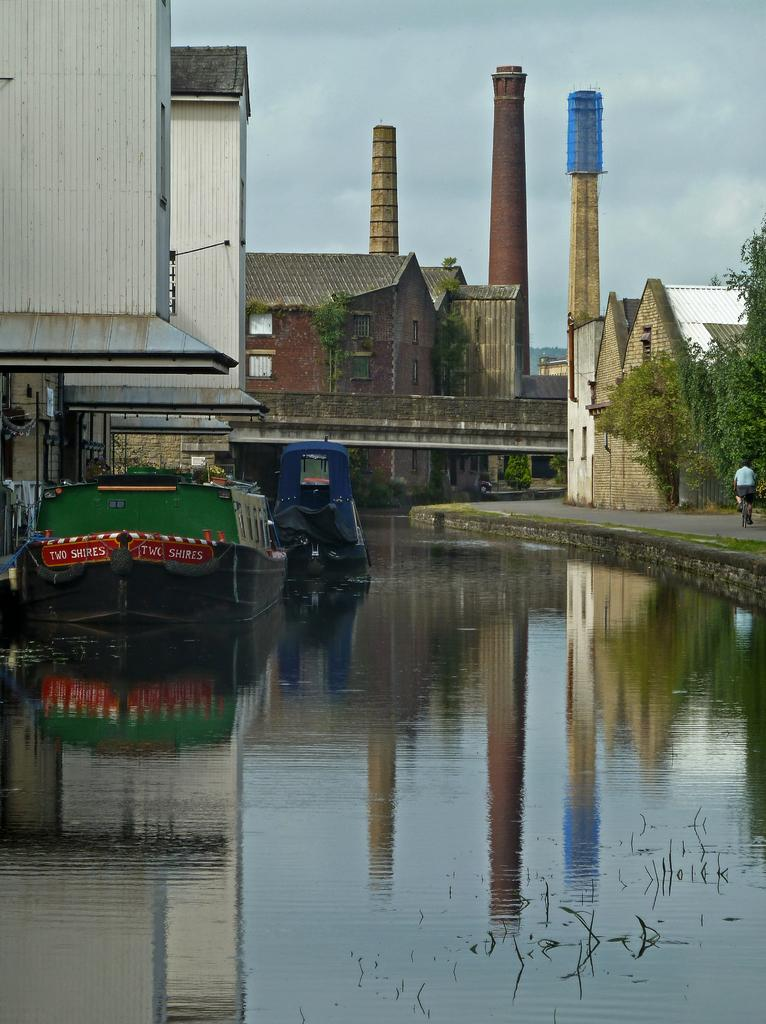What is on the water in the image? There are boats on the water in the image. What can be seen in the distance in the image? There are buildings, trees, and towers in the background of the image. What is the person in the image doing? There is a person riding a bicycle on the road in the image. What type of books can be seen on the boats in the image? There are no books present in the image; it features boats on the water. How does the acoustics of the bicycle affect the sound of the water in the image? There is no information about the acoustics of the bicycle or the sound of the water in the image. 